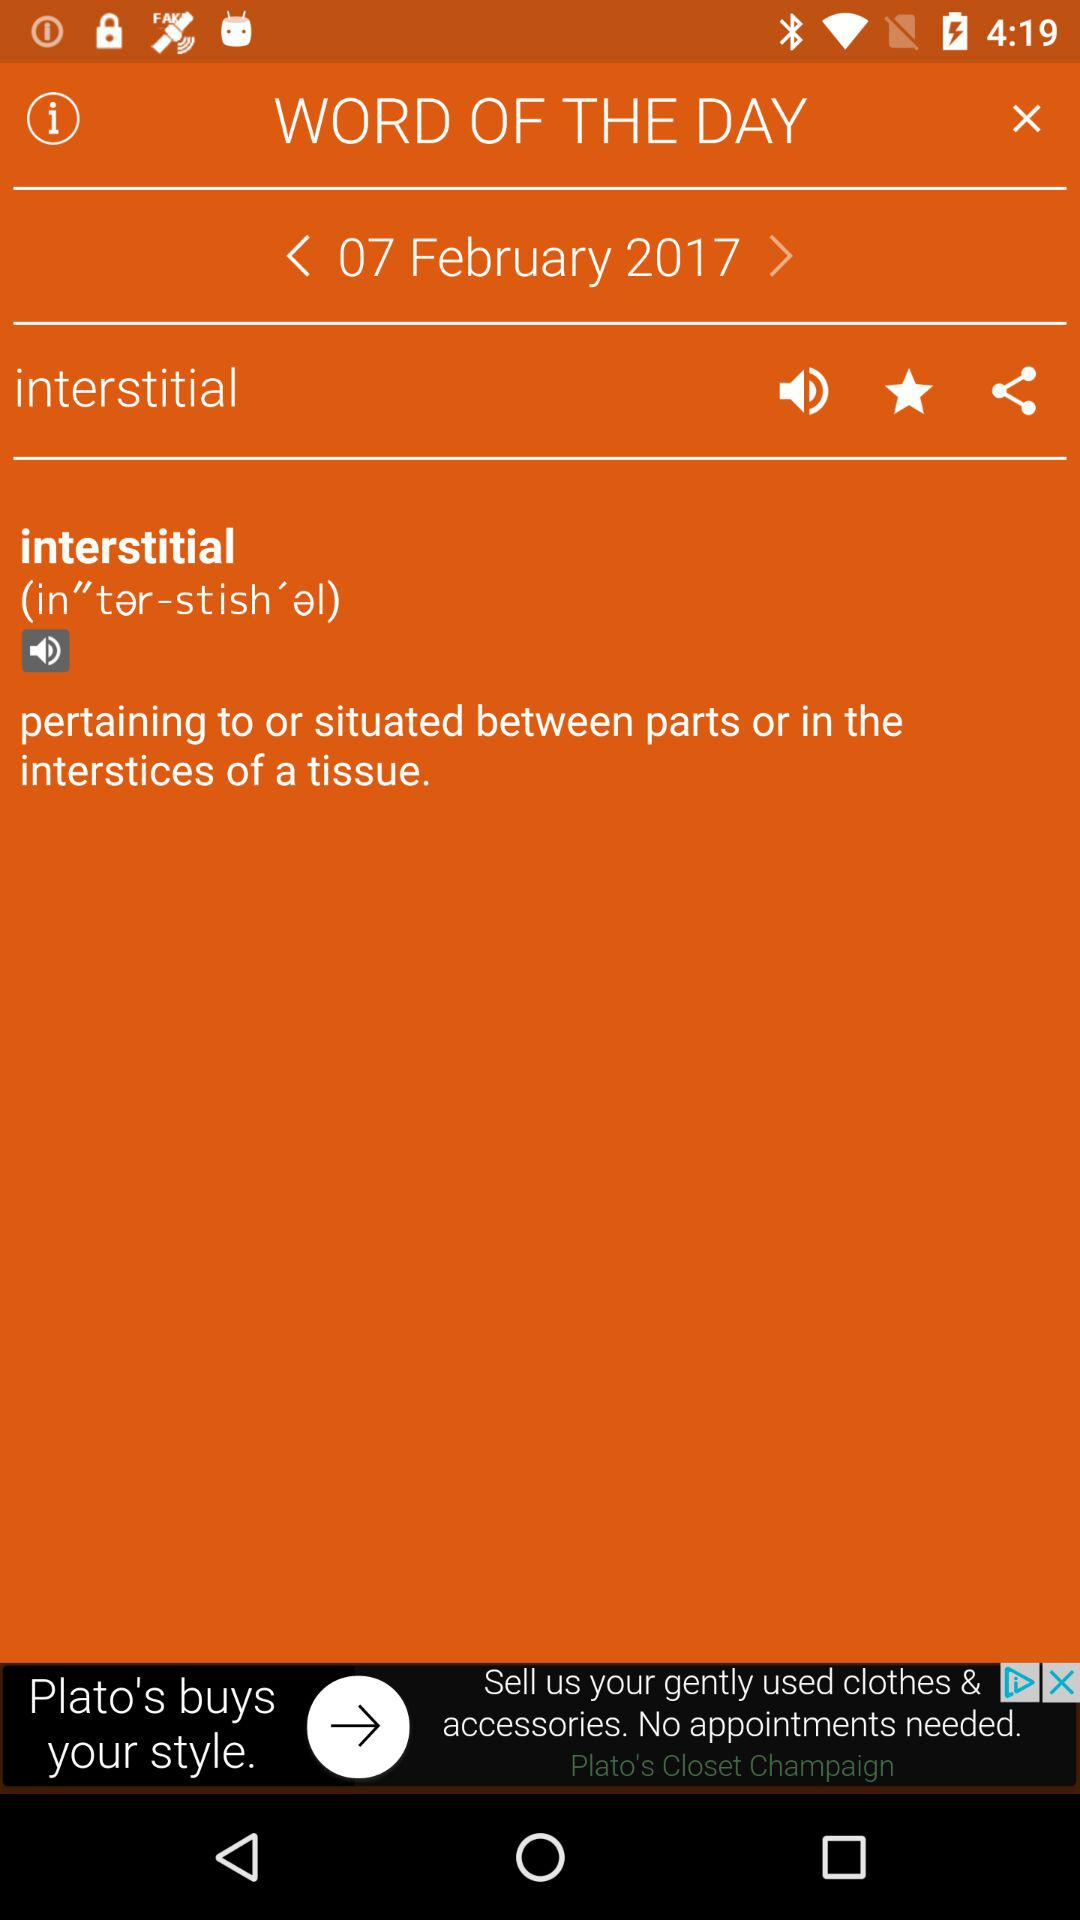What is the mentioned date? The mentioned date is February 7, 2017. 